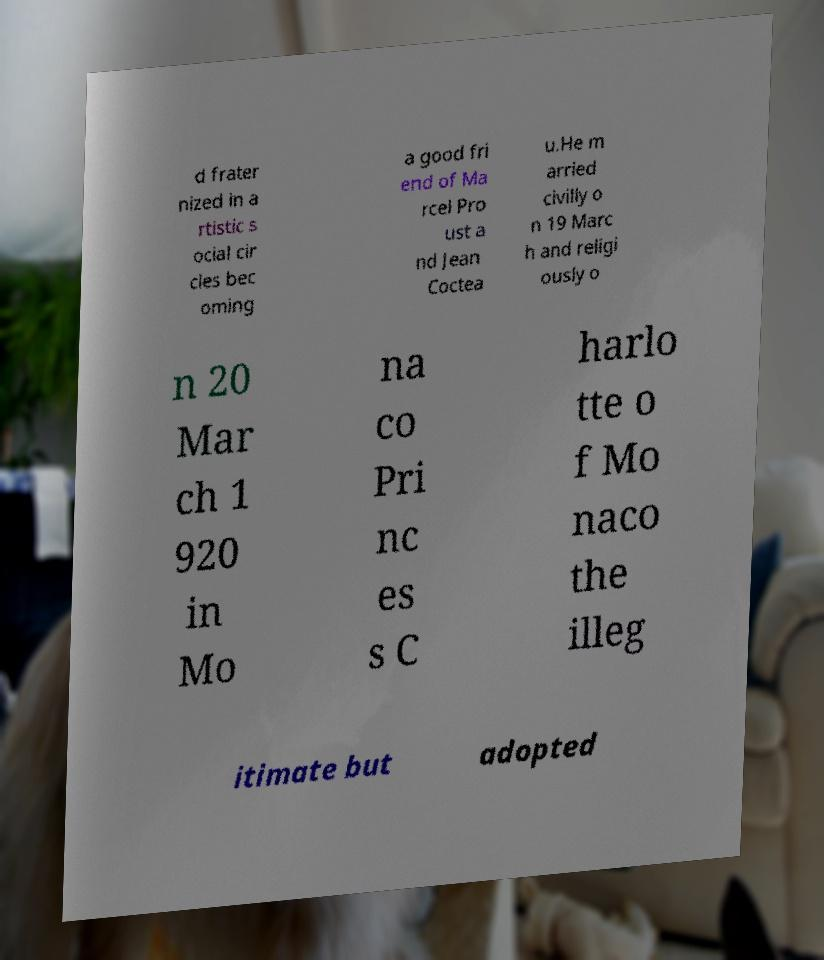For documentation purposes, I need the text within this image transcribed. Could you provide that? d frater nized in a rtistic s ocial cir cles bec oming a good fri end of Ma rcel Pro ust a nd Jean Coctea u.He m arried civilly o n 19 Marc h and religi ously o n 20 Mar ch 1 920 in Mo na co Pri nc es s C harlo tte o f Mo naco the illeg itimate but adopted 